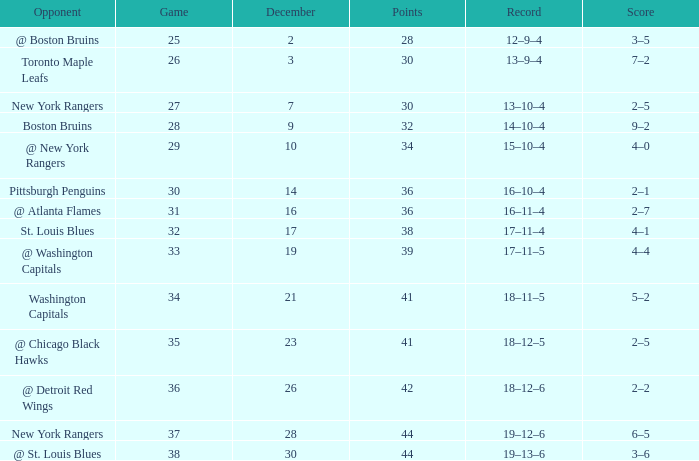Which Game has a Record of 14–10–4, and Points smaller than 32? None. 